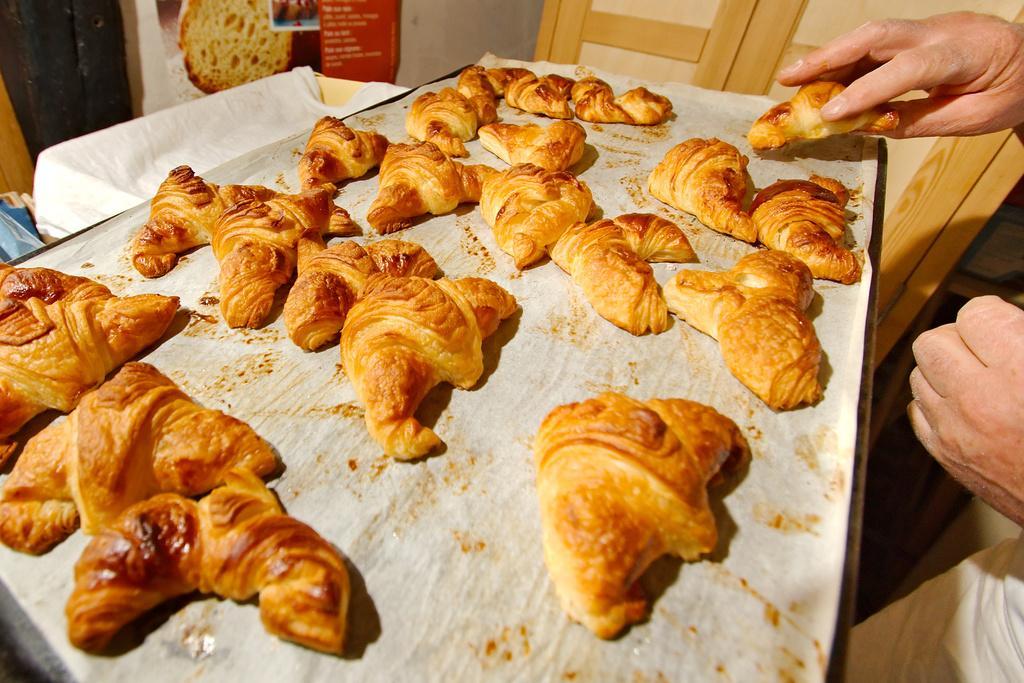Can you describe this image briefly? In this picture I can see there is a food placed on the tray and the person on the right side. In the backdrop I can see there is a poster and there is a wall. 